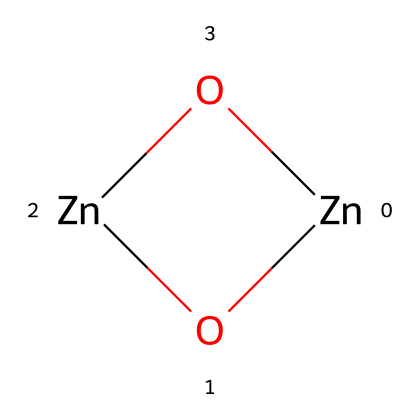What is the main metal component in this chemical structure? The chemical structure displays zinc as the primary metal component, specifically represented by the "Zn" in the SMILES notation.
Answer: zinc How many oxygen atoms are present in the structure? The SMILES representation shows the presence of two "O" atoms, indicating that there are two oxygen atoms in the chemical structure.
Answer: two What is the likely application of this nanomaterial in the context of paints? Given its properties such as UV resistance and quick-drying capabilities, zinc oxide is commonly used in paints for aircraft to provide both durability and protection from UV radiation.
Answer: aircraft paint What type of nanostructure is indicated by the chemical representation? The chemical structure contains a network of zinc and oxygen atoms, indicating a nanocrystalline oxide structure, characteristic of nanomaterials utilized for their enhanced properties.
Answer: nanocrystalline oxide Why is zinc oxide considered effective for UV protection in paints? Zinc oxide exhibits strong UV absorptive properties due to its unique bandgap, making it effective in blocking harmful UV radiation, which is beneficial for protecting painted surfaces such as those on aircraft.
Answer: UV absorptive How does the nanostructuring of zinc oxide contribute to paint performance? The nanostructuring facilitates improved surface interactions and dispersibility in the paint matrix, enhancing the overall performance such as adhesion, drying time, and UV resistance in final application.
Answer: enhanced performance 